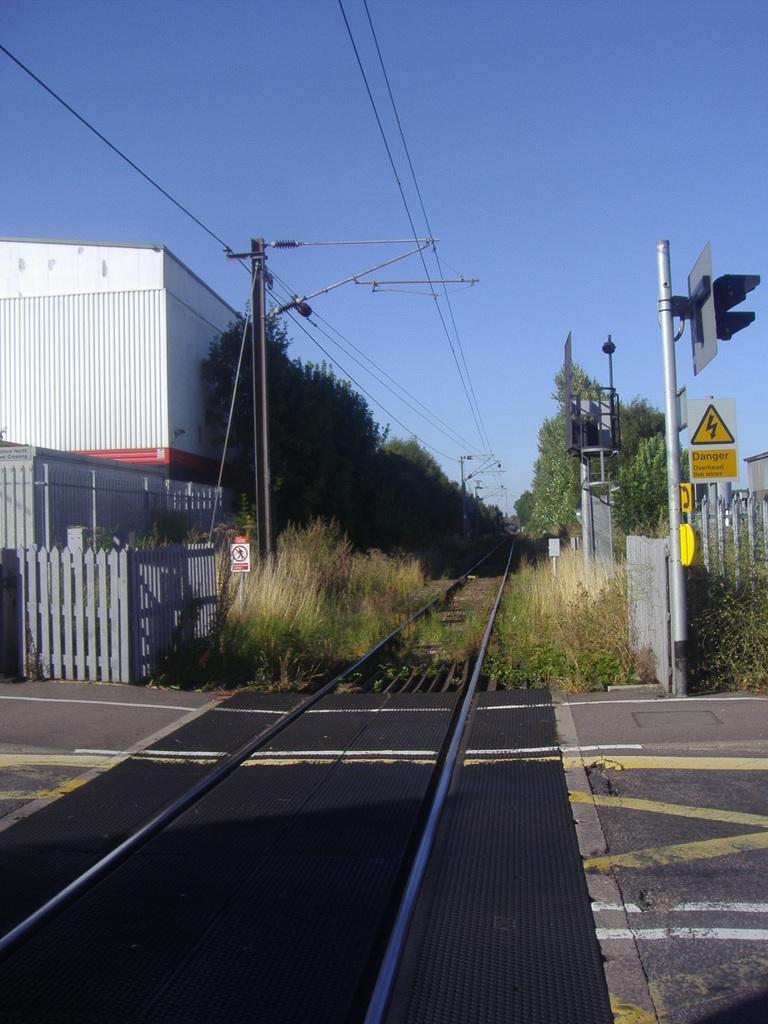What type of structures are present in the image? There are sign boards, lights attached to poles, a railway track, a fence, a shed, and trees in the image. What type of vegetation can be seen in the image? There is grass and plants in the image. What is the background of the image? The sky is visible in the background of the image. What type of swing can be seen in the image? There is no swing present in the image. Who is the manager of the railway track in the image? There is no indication of a manager in the image, as it only shows various structures and objects. 